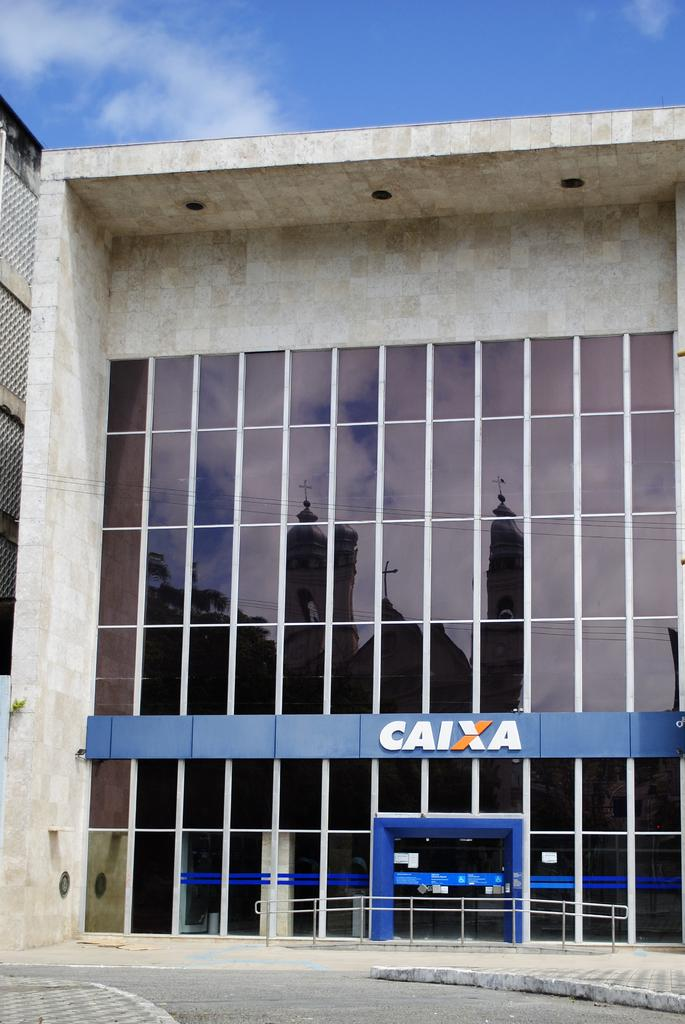What type of structure is visible in the image? There is a building in the image. What feature can be seen near the building? There is a railing in the image. Is there any signage or identification in the image? Yes, there is a name board in the image. What can be seen in the sky in the image? The sky is visible in the image, and there are clouds present. What type of calendar is hanging on the wall in the image? There is no calendar visible in the image. Can you tell me what type of hospital is shown in the image? There is no hospital present in the image; it features a building and other elements. 